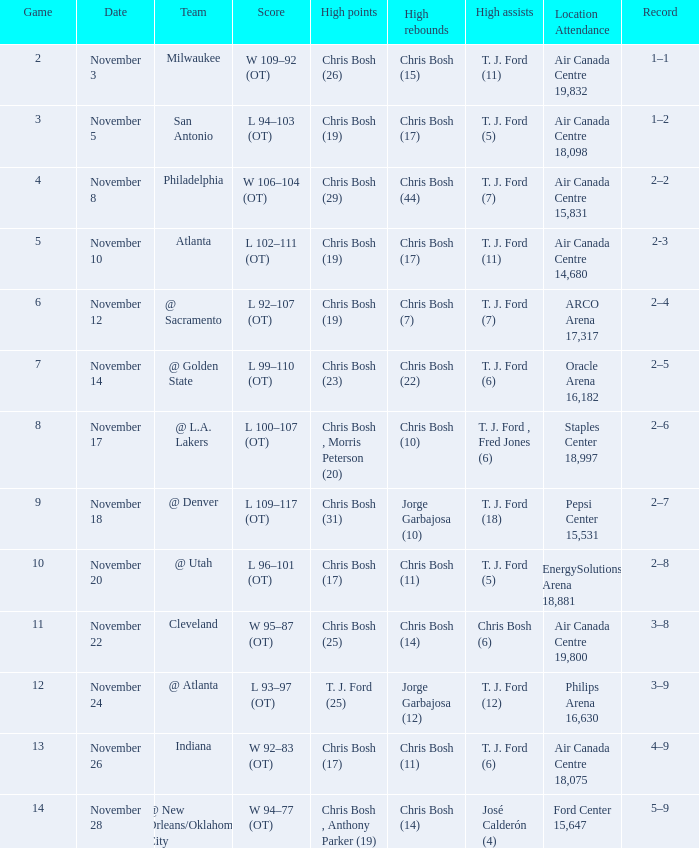Who had high assists when they played against San Antonio? T. J. Ford (5). 